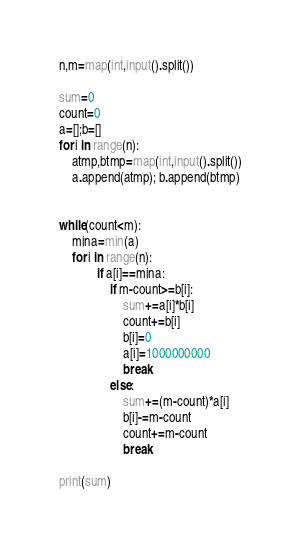<code> <loc_0><loc_0><loc_500><loc_500><_Python_>n,m=map(int,input().split())

sum=0
count=0
a=[];b=[]
for i in range(n):
    atmp,btmp=map(int,input().split())
    a.append(atmp); b.append(btmp)


while(count<m):
    mina=min(a)
    for i in range(n):
            if a[i]==mina:
                if m-count>=b[i]:
                    sum+=a[i]*b[i]
                    count+=b[i]
                    b[i]=0
                    a[i]=1000000000
                    break
                else:
                    sum+=(m-count)*a[i]
                    b[i]-=m-count
                    count+=m-count
                    break

print(sum)</code> 